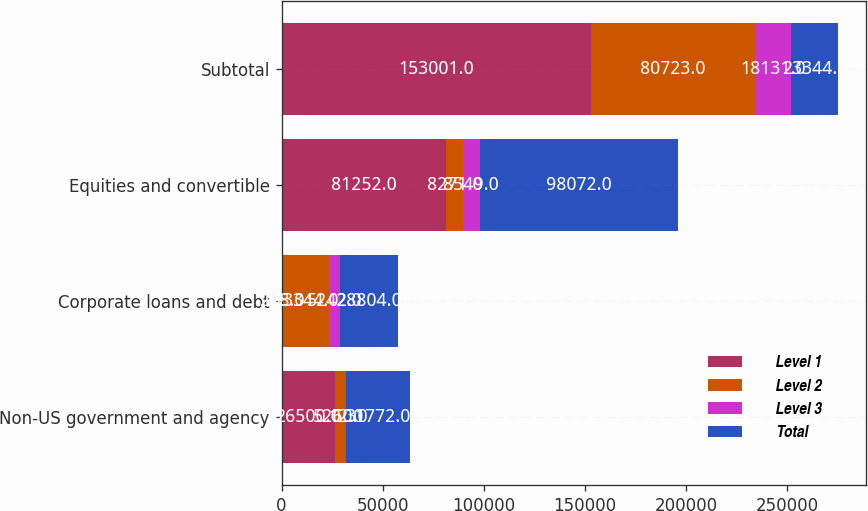Convert chart to OTSL. <chart><loc_0><loc_0><loc_500><loc_500><stacked_bar_chart><ecel><fcel>Non-US government and agency<fcel>Corporate loans and debt<fcel>Equities and convertible<fcel>Subtotal<nl><fcel>Level 1<fcel>26500<fcel>218<fcel>81252<fcel>153001<nl><fcel>Level 2<fcel>5260<fcel>23344<fcel>8271<fcel>80723<nl><fcel>Level 3<fcel>12<fcel>5242<fcel>8549<fcel>18131<nl><fcel>Total<fcel>31772<fcel>28804<fcel>98072<fcel>23344<nl></chart> 